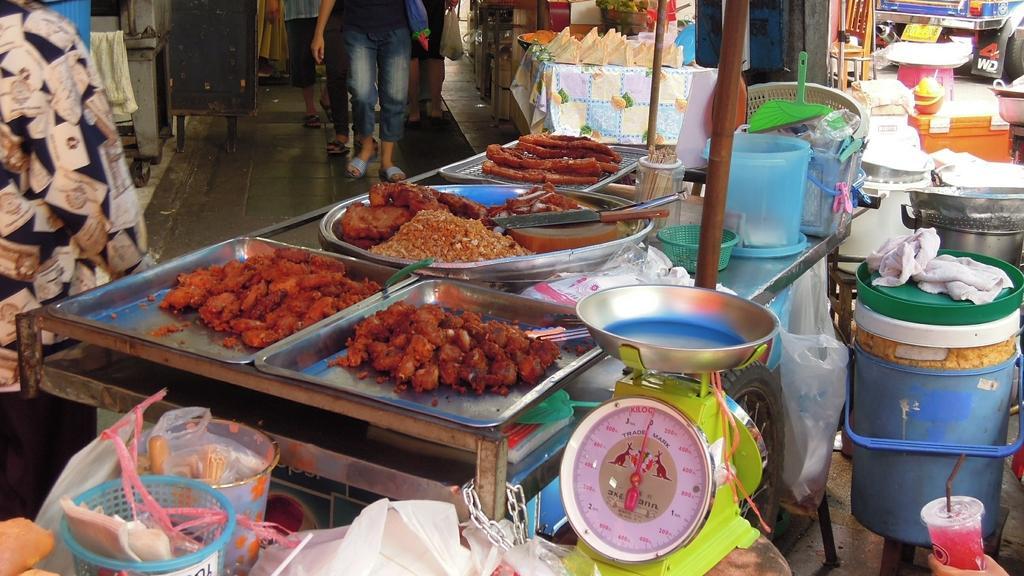How would you summarize this image in a sentence or two? In this image I see few food items over here and I see the weighing machine over here and I see number of things and I see few people over here on this path and I see a vehicle over here and I see a person's hand over here who is holding a glass. 